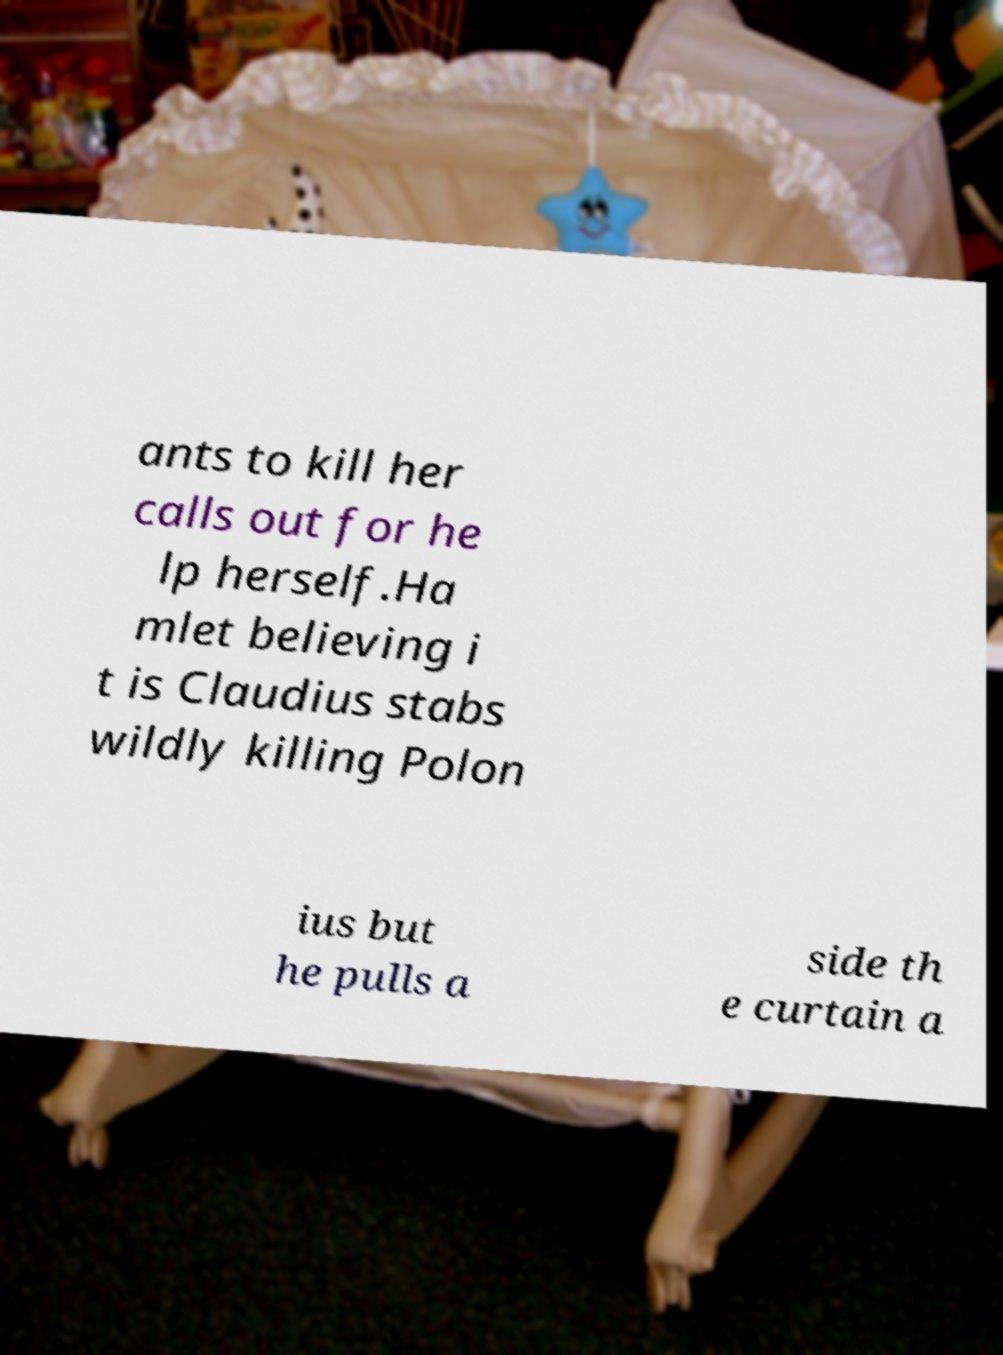Can you read and provide the text displayed in the image?This photo seems to have some interesting text. Can you extract and type it out for me? ants to kill her calls out for he lp herself.Ha mlet believing i t is Claudius stabs wildly killing Polon ius but he pulls a side th e curtain a 